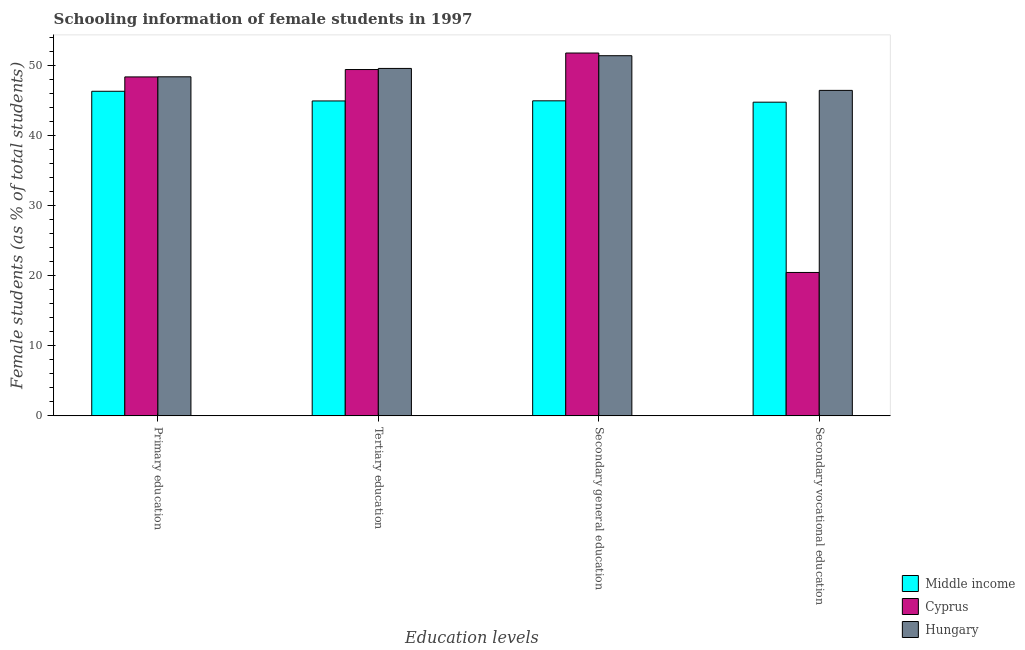How many different coloured bars are there?
Your answer should be compact. 3. How many groups of bars are there?
Give a very brief answer. 4. Are the number of bars per tick equal to the number of legend labels?
Provide a succinct answer. Yes. What is the label of the 4th group of bars from the left?
Offer a terse response. Secondary vocational education. What is the percentage of female students in secondary vocational education in Cyprus?
Your response must be concise. 20.48. Across all countries, what is the maximum percentage of female students in tertiary education?
Your response must be concise. 49.62. Across all countries, what is the minimum percentage of female students in secondary vocational education?
Your answer should be very brief. 20.48. In which country was the percentage of female students in secondary vocational education maximum?
Give a very brief answer. Hungary. In which country was the percentage of female students in secondary education minimum?
Keep it short and to the point. Middle income. What is the total percentage of female students in primary education in the graph?
Ensure brevity in your answer.  143.19. What is the difference between the percentage of female students in tertiary education in Middle income and that in Hungary?
Provide a succinct answer. -4.64. What is the difference between the percentage of female students in secondary education in Middle income and the percentage of female students in secondary vocational education in Cyprus?
Your answer should be compact. 24.51. What is the average percentage of female students in primary education per country?
Offer a terse response. 47.73. What is the difference between the percentage of female students in secondary vocational education and percentage of female students in secondary education in Cyprus?
Your response must be concise. -31.34. In how many countries, is the percentage of female students in secondary education greater than 26 %?
Your answer should be compact. 3. What is the ratio of the percentage of female students in tertiary education in Hungary to that in Middle income?
Ensure brevity in your answer.  1.1. Is the difference between the percentage of female students in secondary education in Middle income and Cyprus greater than the difference between the percentage of female students in tertiary education in Middle income and Cyprus?
Your answer should be compact. No. What is the difference between the highest and the second highest percentage of female students in secondary education?
Ensure brevity in your answer.  0.38. What is the difference between the highest and the lowest percentage of female students in tertiary education?
Make the answer very short. 4.64. In how many countries, is the percentage of female students in tertiary education greater than the average percentage of female students in tertiary education taken over all countries?
Your answer should be compact. 2. Is the sum of the percentage of female students in tertiary education in Hungary and Cyprus greater than the maximum percentage of female students in primary education across all countries?
Your answer should be very brief. Yes. What does the 2nd bar from the left in Primary education represents?
Provide a short and direct response. Cyprus. What does the 2nd bar from the right in Secondary vocational education represents?
Your response must be concise. Cyprus. Is it the case that in every country, the sum of the percentage of female students in primary education and percentage of female students in tertiary education is greater than the percentage of female students in secondary education?
Provide a short and direct response. Yes. How many bars are there?
Make the answer very short. 12. Are the values on the major ticks of Y-axis written in scientific E-notation?
Give a very brief answer. No. Does the graph contain any zero values?
Provide a short and direct response. No. Does the graph contain grids?
Your answer should be very brief. No. Where does the legend appear in the graph?
Ensure brevity in your answer.  Bottom right. How are the legend labels stacked?
Keep it short and to the point. Vertical. What is the title of the graph?
Provide a succinct answer. Schooling information of female students in 1997. Does "Belarus" appear as one of the legend labels in the graph?
Ensure brevity in your answer.  No. What is the label or title of the X-axis?
Ensure brevity in your answer.  Education levels. What is the label or title of the Y-axis?
Offer a very short reply. Female students (as % of total students). What is the Female students (as % of total students) in Middle income in Primary education?
Offer a very short reply. 46.36. What is the Female students (as % of total students) in Cyprus in Primary education?
Give a very brief answer. 48.41. What is the Female students (as % of total students) in Hungary in Primary education?
Keep it short and to the point. 48.43. What is the Female students (as % of total students) of Middle income in Tertiary education?
Provide a succinct answer. 44.98. What is the Female students (as % of total students) of Cyprus in Tertiary education?
Your answer should be compact. 49.46. What is the Female students (as % of total students) in Hungary in Tertiary education?
Give a very brief answer. 49.62. What is the Female students (as % of total students) of Middle income in Secondary general education?
Give a very brief answer. 44.99. What is the Female students (as % of total students) of Cyprus in Secondary general education?
Offer a very short reply. 51.82. What is the Female students (as % of total students) in Hungary in Secondary general education?
Offer a terse response. 51.44. What is the Female students (as % of total students) in Middle income in Secondary vocational education?
Give a very brief answer. 44.8. What is the Female students (as % of total students) in Cyprus in Secondary vocational education?
Make the answer very short. 20.48. What is the Female students (as % of total students) of Hungary in Secondary vocational education?
Offer a very short reply. 46.49. Across all Education levels, what is the maximum Female students (as % of total students) in Middle income?
Offer a very short reply. 46.36. Across all Education levels, what is the maximum Female students (as % of total students) of Cyprus?
Give a very brief answer. 51.82. Across all Education levels, what is the maximum Female students (as % of total students) of Hungary?
Your response must be concise. 51.44. Across all Education levels, what is the minimum Female students (as % of total students) of Middle income?
Your answer should be compact. 44.8. Across all Education levels, what is the minimum Female students (as % of total students) of Cyprus?
Provide a short and direct response. 20.48. Across all Education levels, what is the minimum Female students (as % of total students) of Hungary?
Provide a short and direct response. 46.49. What is the total Female students (as % of total students) in Middle income in the graph?
Offer a terse response. 181.13. What is the total Female students (as % of total students) in Cyprus in the graph?
Make the answer very short. 170.17. What is the total Female students (as % of total students) in Hungary in the graph?
Provide a short and direct response. 195.97. What is the difference between the Female students (as % of total students) in Middle income in Primary education and that in Tertiary education?
Give a very brief answer. 1.38. What is the difference between the Female students (as % of total students) in Cyprus in Primary education and that in Tertiary education?
Ensure brevity in your answer.  -1.05. What is the difference between the Female students (as % of total students) of Hungary in Primary education and that in Tertiary education?
Your answer should be compact. -1.19. What is the difference between the Female students (as % of total students) of Middle income in Primary education and that in Secondary general education?
Your answer should be compact. 1.36. What is the difference between the Female students (as % of total students) of Cyprus in Primary education and that in Secondary general education?
Ensure brevity in your answer.  -3.41. What is the difference between the Female students (as % of total students) of Hungary in Primary education and that in Secondary general education?
Offer a terse response. -3.01. What is the difference between the Female students (as % of total students) in Middle income in Primary education and that in Secondary vocational education?
Provide a succinct answer. 1.56. What is the difference between the Female students (as % of total students) in Cyprus in Primary education and that in Secondary vocational education?
Your answer should be very brief. 27.93. What is the difference between the Female students (as % of total students) in Hungary in Primary education and that in Secondary vocational education?
Your answer should be very brief. 1.94. What is the difference between the Female students (as % of total students) of Middle income in Tertiary education and that in Secondary general education?
Give a very brief answer. -0.02. What is the difference between the Female students (as % of total students) of Cyprus in Tertiary education and that in Secondary general education?
Offer a very short reply. -2.36. What is the difference between the Female students (as % of total students) of Hungary in Tertiary education and that in Secondary general education?
Provide a short and direct response. -1.82. What is the difference between the Female students (as % of total students) in Middle income in Tertiary education and that in Secondary vocational education?
Offer a terse response. 0.18. What is the difference between the Female students (as % of total students) of Cyprus in Tertiary education and that in Secondary vocational education?
Offer a terse response. 28.98. What is the difference between the Female students (as % of total students) in Hungary in Tertiary education and that in Secondary vocational education?
Your answer should be very brief. 3.13. What is the difference between the Female students (as % of total students) in Middle income in Secondary general education and that in Secondary vocational education?
Your answer should be compact. 0.19. What is the difference between the Female students (as % of total students) of Cyprus in Secondary general education and that in Secondary vocational education?
Ensure brevity in your answer.  31.34. What is the difference between the Female students (as % of total students) of Hungary in Secondary general education and that in Secondary vocational education?
Your answer should be very brief. 4.95. What is the difference between the Female students (as % of total students) in Middle income in Primary education and the Female students (as % of total students) in Cyprus in Tertiary education?
Your answer should be compact. -3.1. What is the difference between the Female students (as % of total students) in Middle income in Primary education and the Female students (as % of total students) in Hungary in Tertiary education?
Provide a short and direct response. -3.26. What is the difference between the Female students (as % of total students) in Cyprus in Primary education and the Female students (as % of total students) in Hungary in Tertiary education?
Make the answer very short. -1.21. What is the difference between the Female students (as % of total students) of Middle income in Primary education and the Female students (as % of total students) of Cyprus in Secondary general education?
Make the answer very short. -5.46. What is the difference between the Female students (as % of total students) of Middle income in Primary education and the Female students (as % of total students) of Hungary in Secondary general education?
Your answer should be very brief. -5.08. What is the difference between the Female students (as % of total students) of Cyprus in Primary education and the Female students (as % of total students) of Hungary in Secondary general education?
Give a very brief answer. -3.03. What is the difference between the Female students (as % of total students) in Middle income in Primary education and the Female students (as % of total students) in Cyprus in Secondary vocational education?
Give a very brief answer. 25.88. What is the difference between the Female students (as % of total students) in Middle income in Primary education and the Female students (as % of total students) in Hungary in Secondary vocational education?
Your answer should be very brief. -0.13. What is the difference between the Female students (as % of total students) of Cyprus in Primary education and the Female students (as % of total students) of Hungary in Secondary vocational education?
Your response must be concise. 1.92. What is the difference between the Female students (as % of total students) of Middle income in Tertiary education and the Female students (as % of total students) of Cyprus in Secondary general education?
Offer a very short reply. -6.85. What is the difference between the Female students (as % of total students) in Middle income in Tertiary education and the Female students (as % of total students) in Hungary in Secondary general education?
Offer a terse response. -6.46. What is the difference between the Female students (as % of total students) of Cyprus in Tertiary education and the Female students (as % of total students) of Hungary in Secondary general education?
Give a very brief answer. -1.98. What is the difference between the Female students (as % of total students) in Middle income in Tertiary education and the Female students (as % of total students) in Cyprus in Secondary vocational education?
Provide a succinct answer. 24.5. What is the difference between the Female students (as % of total students) in Middle income in Tertiary education and the Female students (as % of total students) in Hungary in Secondary vocational education?
Keep it short and to the point. -1.51. What is the difference between the Female students (as % of total students) of Cyprus in Tertiary education and the Female students (as % of total students) of Hungary in Secondary vocational education?
Keep it short and to the point. 2.98. What is the difference between the Female students (as % of total students) of Middle income in Secondary general education and the Female students (as % of total students) of Cyprus in Secondary vocational education?
Give a very brief answer. 24.51. What is the difference between the Female students (as % of total students) in Middle income in Secondary general education and the Female students (as % of total students) in Hungary in Secondary vocational education?
Offer a terse response. -1.49. What is the difference between the Female students (as % of total students) of Cyprus in Secondary general education and the Female students (as % of total students) of Hungary in Secondary vocational education?
Provide a succinct answer. 5.34. What is the average Female students (as % of total students) of Middle income per Education levels?
Keep it short and to the point. 45.28. What is the average Female students (as % of total students) of Cyprus per Education levels?
Make the answer very short. 42.54. What is the average Female students (as % of total students) in Hungary per Education levels?
Your answer should be very brief. 48.99. What is the difference between the Female students (as % of total students) in Middle income and Female students (as % of total students) in Cyprus in Primary education?
Give a very brief answer. -2.05. What is the difference between the Female students (as % of total students) in Middle income and Female students (as % of total students) in Hungary in Primary education?
Provide a succinct answer. -2.07. What is the difference between the Female students (as % of total students) of Cyprus and Female students (as % of total students) of Hungary in Primary education?
Provide a succinct answer. -0.02. What is the difference between the Female students (as % of total students) in Middle income and Female students (as % of total students) in Cyprus in Tertiary education?
Your response must be concise. -4.49. What is the difference between the Female students (as % of total students) in Middle income and Female students (as % of total students) in Hungary in Tertiary education?
Keep it short and to the point. -4.64. What is the difference between the Female students (as % of total students) of Cyprus and Female students (as % of total students) of Hungary in Tertiary education?
Give a very brief answer. -0.16. What is the difference between the Female students (as % of total students) in Middle income and Female students (as % of total students) in Cyprus in Secondary general education?
Your answer should be compact. -6.83. What is the difference between the Female students (as % of total students) in Middle income and Female students (as % of total students) in Hungary in Secondary general education?
Your response must be concise. -6.44. What is the difference between the Female students (as % of total students) in Cyprus and Female students (as % of total students) in Hungary in Secondary general education?
Keep it short and to the point. 0.38. What is the difference between the Female students (as % of total students) in Middle income and Female students (as % of total students) in Cyprus in Secondary vocational education?
Offer a very short reply. 24.32. What is the difference between the Female students (as % of total students) in Middle income and Female students (as % of total students) in Hungary in Secondary vocational education?
Your response must be concise. -1.69. What is the difference between the Female students (as % of total students) of Cyprus and Female students (as % of total students) of Hungary in Secondary vocational education?
Your response must be concise. -26. What is the ratio of the Female students (as % of total students) in Middle income in Primary education to that in Tertiary education?
Keep it short and to the point. 1.03. What is the ratio of the Female students (as % of total students) of Cyprus in Primary education to that in Tertiary education?
Provide a short and direct response. 0.98. What is the ratio of the Female students (as % of total students) of Hungary in Primary education to that in Tertiary education?
Give a very brief answer. 0.98. What is the ratio of the Female students (as % of total students) of Middle income in Primary education to that in Secondary general education?
Provide a short and direct response. 1.03. What is the ratio of the Female students (as % of total students) of Cyprus in Primary education to that in Secondary general education?
Provide a short and direct response. 0.93. What is the ratio of the Female students (as % of total students) in Hungary in Primary education to that in Secondary general education?
Your answer should be compact. 0.94. What is the ratio of the Female students (as % of total students) of Middle income in Primary education to that in Secondary vocational education?
Give a very brief answer. 1.03. What is the ratio of the Female students (as % of total students) in Cyprus in Primary education to that in Secondary vocational education?
Provide a short and direct response. 2.36. What is the ratio of the Female students (as % of total students) in Hungary in Primary education to that in Secondary vocational education?
Give a very brief answer. 1.04. What is the ratio of the Female students (as % of total students) of Middle income in Tertiary education to that in Secondary general education?
Keep it short and to the point. 1. What is the ratio of the Female students (as % of total students) of Cyprus in Tertiary education to that in Secondary general education?
Make the answer very short. 0.95. What is the ratio of the Female students (as % of total students) of Hungary in Tertiary education to that in Secondary general education?
Offer a very short reply. 0.96. What is the ratio of the Female students (as % of total students) of Cyprus in Tertiary education to that in Secondary vocational education?
Provide a succinct answer. 2.42. What is the ratio of the Female students (as % of total students) in Hungary in Tertiary education to that in Secondary vocational education?
Offer a terse response. 1.07. What is the ratio of the Female students (as % of total students) in Middle income in Secondary general education to that in Secondary vocational education?
Keep it short and to the point. 1. What is the ratio of the Female students (as % of total students) in Cyprus in Secondary general education to that in Secondary vocational education?
Provide a short and direct response. 2.53. What is the ratio of the Female students (as % of total students) in Hungary in Secondary general education to that in Secondary vocational education?
Keep it short and to the point. 1.11. What is the difference between the highest and the second highest Female students (as % of total students) in Middle income?
Keep it short and to the point. 1.36. What is the difference between the highest and the second highest Female students (as % of total students) in Cyprus?
Your answer should be compact. 2.36. What is the difference between the highest and the second highest Female students (as % of total students) of Hungary?
Offer a terse response. 1.82. What is the difference between the highest and the lowest Female students (as % of total students) in Middle income?
Your answer should be compact. 1.56. What is the difference between the highest and the lowest Female students (as % of total students) in Cyprus?
Offer a terse response. 31.34. What is the difference between the highest and the lowest Female students (as % of total students) of Hungary?
Ensure brevity in your answer.  4.95. 